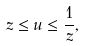Convert formula to latex. <formula><loc_0><loc_0><loc_500><loc_500>z \leq u \leq \frac { 1 } { z } ,</formula> 